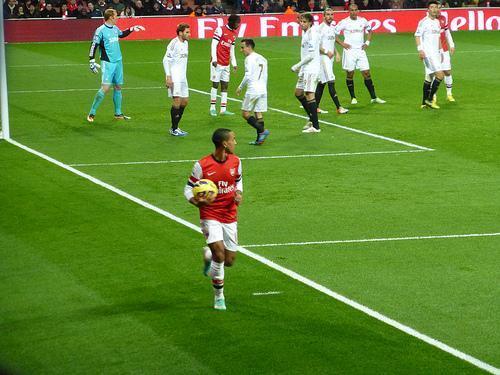How many players are there?
Give a very brief answer. 10. 